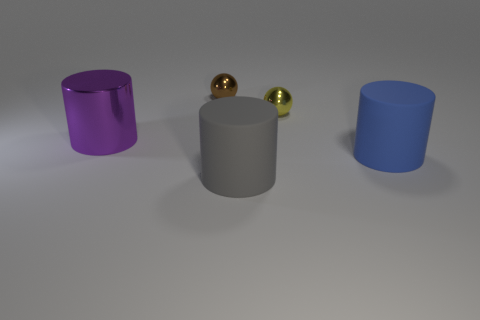There is a large matte cylinder that is right of the gray matte cylinder; what color is it?
Provide a succinct answer. Blue. The big rubber thing that is to the left of the large rubber cylinder to the right of the yellow shiny thing is what color?
Make the answer very short. Gray. What is the color of the other metal thing that is the same size as the yellow thing?
Offer a very short reply. Brown. What number of things are behind the big purple cylinder and in front of the large purple cylinder?
Keep it short and to the point. 0. There is a large object that is left of the big blue rubber thing and in front of the big metallic object; what material is it?
Offer a terse response. Rubber. Are there fewer purple objects that are in front of the purple metal cylinder than small things in front of the brown metal object?
Keep it short and to the point. Yes. What size is the brown thing that is made of the same material as the large purple cylinder?
Make the answer very short. Small. Are the gray object and the yellow ball that is on the left side of the big blue cylinder made of the same material?
Provide a succinct answer. No. There is a blue thing that is the same shape as the large purple thing; what is it made of?
Offer a terse response. Rubber. Does the large thing behind the blue thing have the same material as the large object on the right side of the yellow shiny thing?
Your answer should be compact. No. 